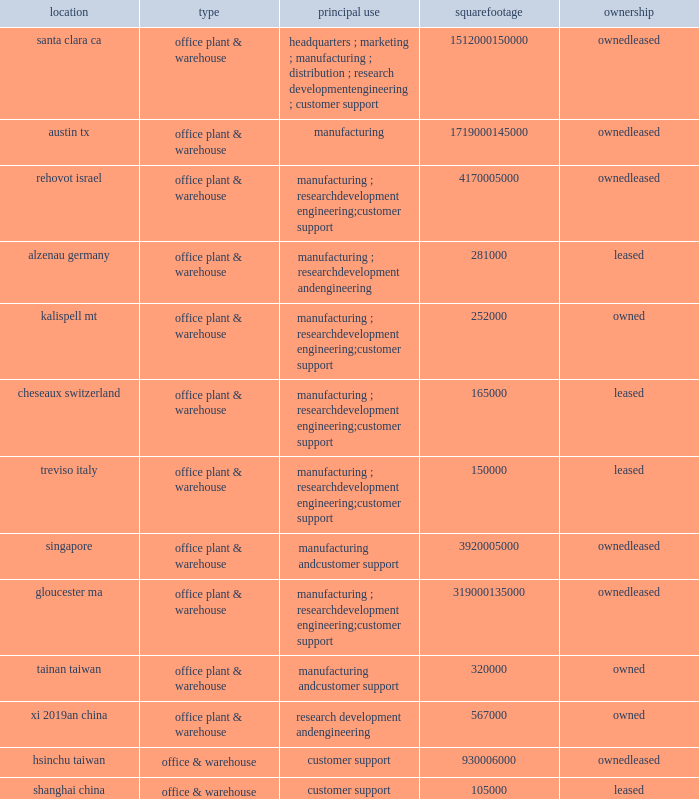Item 2 : properties information concerning applied 2019s principal properties at october 28 , 2012 is set forth below : location type principal use square footage ownership santa clara , ca .
Office , plant & warehouse headquarters ; marketing ; manufacturing ; distribution ; research , development , engineering ; customer support 1512000 150000 leased austin , tx .
Office , plant & warehouse manufacturing 1719000 145000 leased rehovot , israel .
Office , plant & warehouse manufacturing ; research , development , engineering ; customer support 417000 leased alzenau , germany .
Office , plant & warehouse manufacturing ; research , development and engineering 281000 leased kalispell , mt .
Office , plant & warehouse manufacturing ; research , development , engineering ; customer support 252000 owned cheseaux , switzerland .
Office , plant & warehouse manufacturing ; research , development , engineering ; customer support 165000 leased treviso , italy .
Office , plant & warehouse manufacturing ; research , development , engineering ; customer support 150000 leased singapore .
Office , plant & warehouse manufacturing and customer support 392000 leased gloucester , ma .
Office , plant & warehouse manufacturing ; research , development , engineering ; customer support 319000 135000 leased tainan , taiwan .
Office , plant & warehouse manufacturing and customer support 320000 owned xi 2019an , china .
Office , plant & warehouse research , development and engineering 567000 owned hsinchu , taiwan .
Office & warehouse customer support 93000 leased .
Because of the interrelation of applied 2019s operations , properties within a country may be shared by the segments operating within that country .
Products in the silicon systems group are manufactured in austin , texas ; gloucester , massachusetts ; rehovot , israel ; and singapore .
Remanufactured products in the applied global services segment are produced primarily in austin , texas .
Products in the display segment are manufactured in santa clara , california ; alzenau , germany ; and tainan , taiwan .
Products in the energy and environmental solutions segment are primarily manufactured in alzenau , germany ; cheseaux , switzerland ; and treviso , italy .
In addition to the above properties , applied leases office space for marketing , sales , engineering and customer support offices in 79 locations throughout the world : 17 in europe , 23 in japan , 16 in north america ( principally the united states ) , 7 in china , 7 in korea , 6 in southeast asia , and 3 in taiwan .
Applied also owns 112 acres of buildable land in texas that could accommodate approximately 1708000 square feet of additional building space , 12.5 acres in california that could accommodate approximately 400000 square feet of additional building space , 10.8 acres in massachusetts that could accommodate approximately 65000 square feet of additional building space and 10 acres in israel that could accommodate approximately 111000 square feet of additional building space .
Applied also leases 4 acres in italy that could accommodate approximately 180000 square feet of additional building space .
Applied considers the properties that it owns or leases as adequate to meet its current and future requirements .
Applied regularly assesses the size , capability and location of its global infrastructure and periodically makes adjustments based on these assessments. .
What is the total square footage of office & warehouse customer support 93000 leased in taiwan? 
Computations: (320000 + 930006000)
Answer: 930326000.0. 